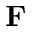Convert formula to latex. <formula><loc_0><loc_0><loc_500><loc_500>{ F }</formula> 